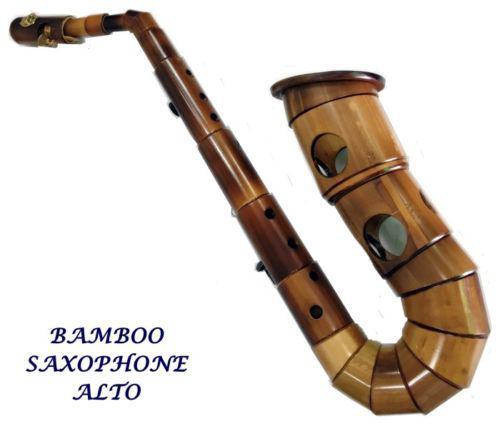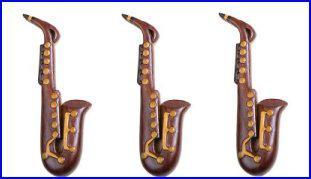The first image is the image on the left, the second image is the image on the right. Considering the images on both sides, is "One of the images contains at least two saxophones." valid? Answer yes or no. Yes. 